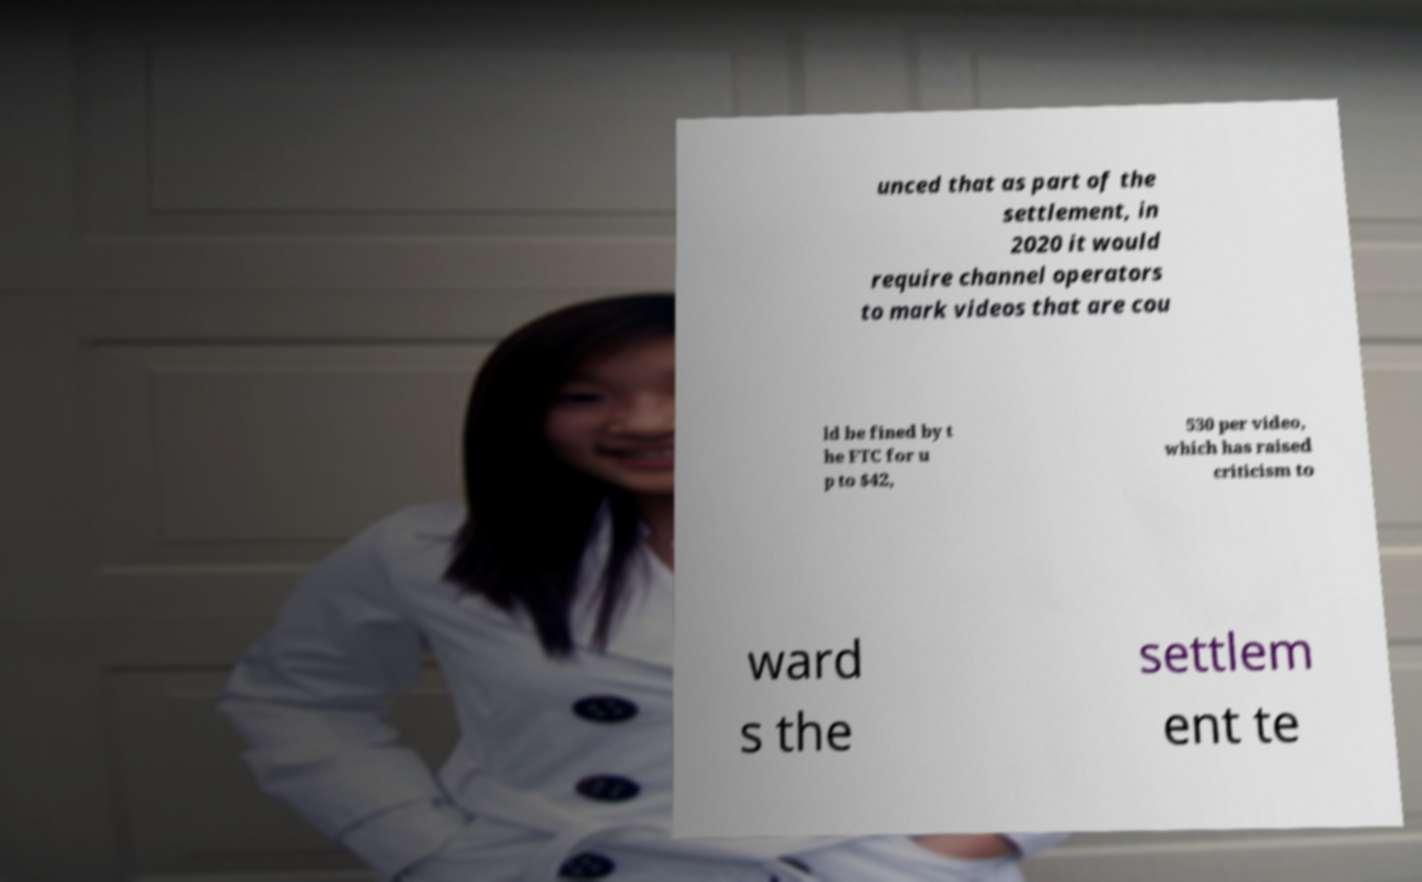Please read and relay the text visible in this image. What does it say? unced that as part of the settlement, in 2020 it would require channel operators to mark videos that are cou ld be fined by t he FTC for u p to $42, 530 per video, which has raised criticism to ward s the settlem ent te 